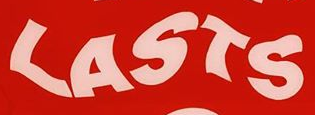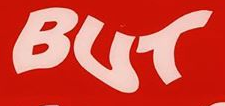Transcribe the words shown in these images in order, separated by a semicolon. LASTS; BUT 